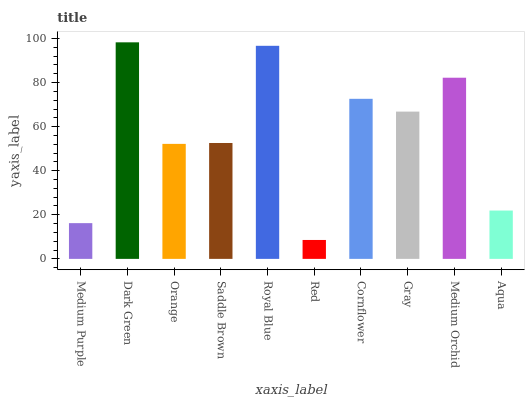Is Red the minimum?
Answer yes or no. Yes. Is Dark Green the maximum?
Answer yes or no. Yes. Is Orange the minimum?
Answer yes or no. No. Is Orange the maximum?
Answer yes or no. No. Is Dark Green greater than Orange?
Answer yes or no. Yes. Is Orange less than Dark Green?
Answer yes or no. Yes. Is Orange greater than Dark Green?
Answer yes or no. No. Is Dark Green less than Orange?
Answer yes or no. No. Is Gray the high median?
Answer yes or no. Yes. Is Saddle Brown the low median?
Answer yes or no. Yes. Is Dark Green the high median?
Answer yes or no. No. Is Medium Orchid the low median?
Answer yes or no. No. 